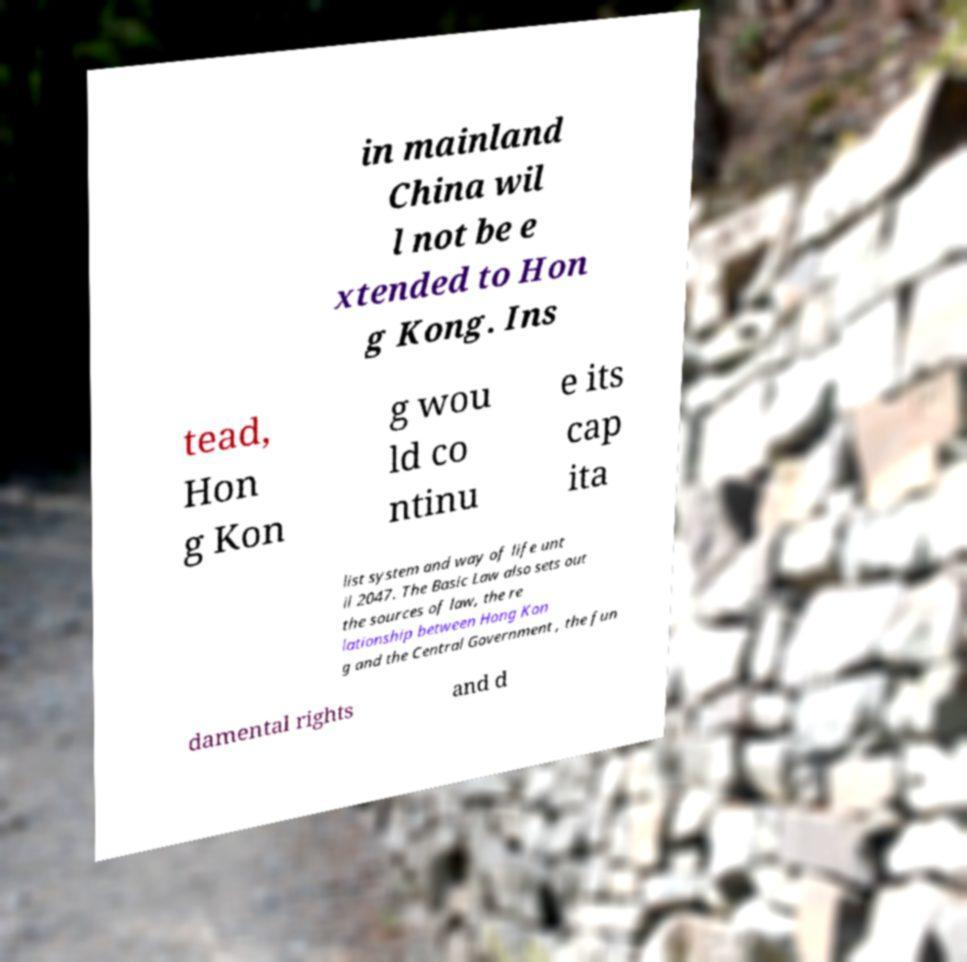Could you assist in decoding the text presented in this image and type it out clearly? in mainland China wil l not be e xtended to Hon g Kong. Ins tead, Hon g Kon g wou ld co ntinu e its cap ita list system and way of life unt il 2047. The Basic Law also sets out the sources of law, the re lationship between Hong Kon g and the Central Government , the fun damental rights and d 